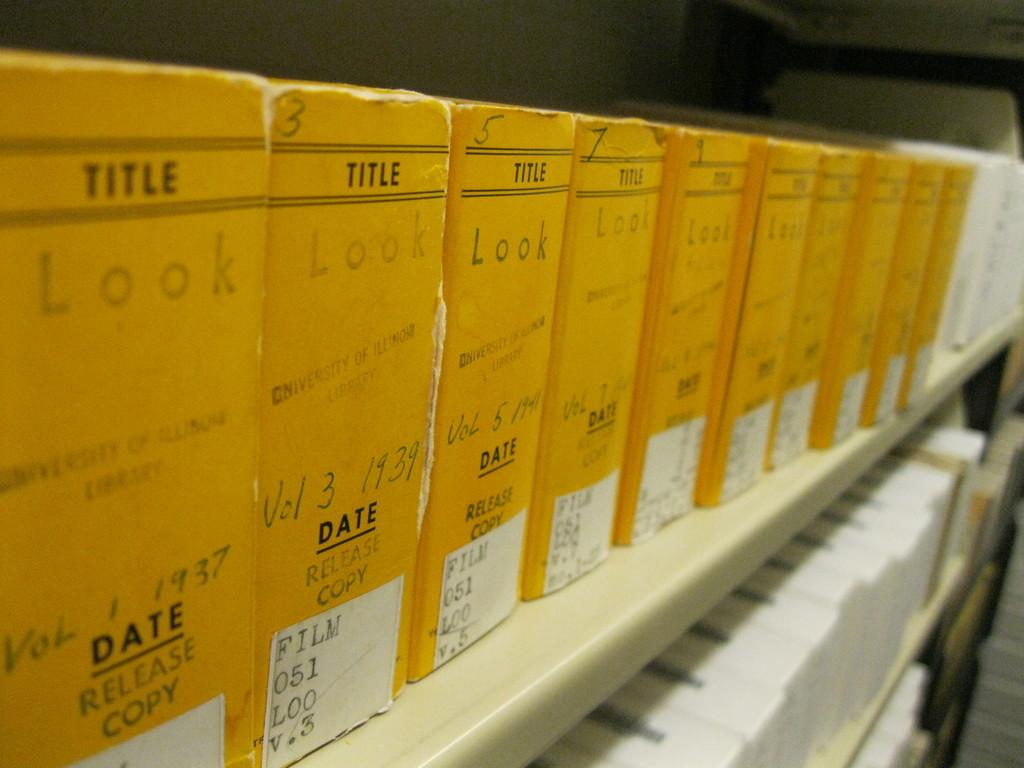Provide a one-sentence caption for the provided image. All the volumes have the Title and date on them. 